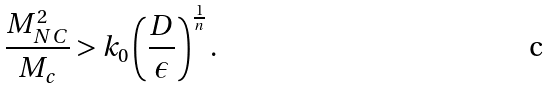<formula> <loc_0><loc_0><loc_500><loc_500>\frac { M ^ { 2 } _ { N C } } { M _ { c } } > k _ { 0 } \left ( \frac { D } { \epsilon } \right ) ^ { \frac { 1 } { n } } .</formula> 